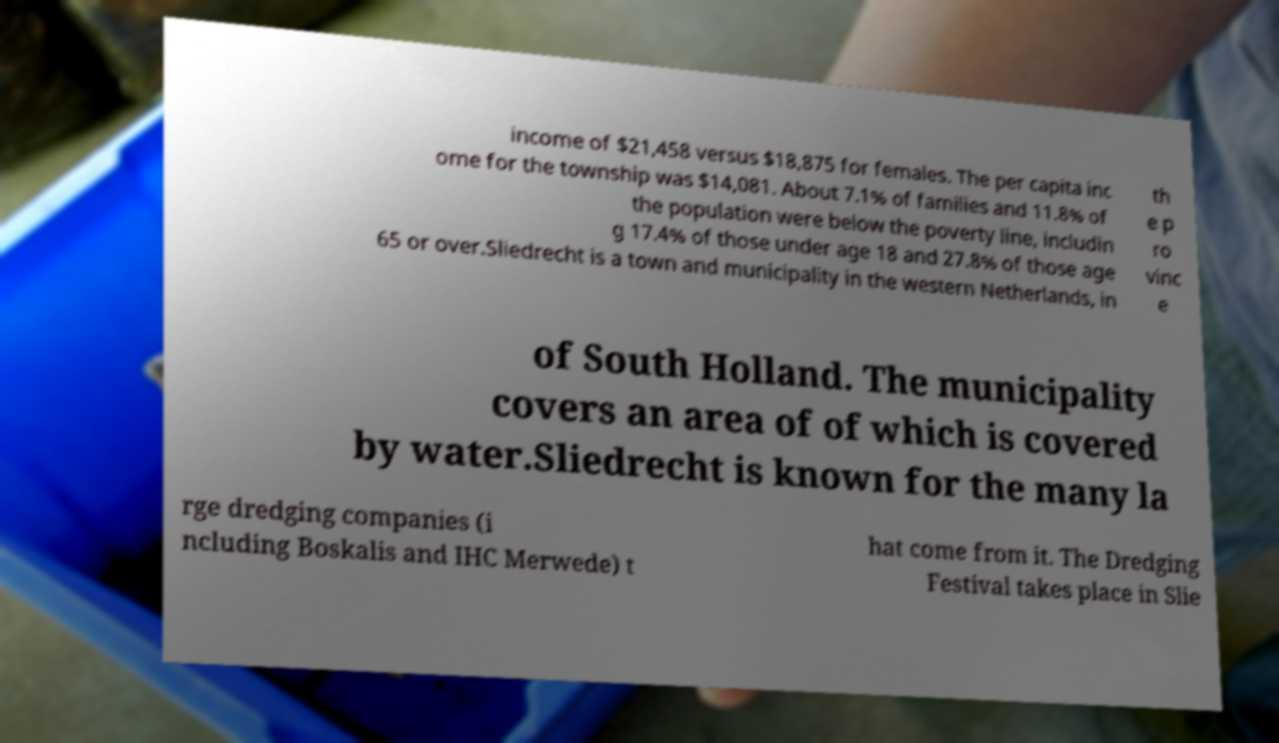Can you accurately transcribe the text from the provided image for me? income of $21,458 versus $18,875 for females. The per capita inc ome for the township was $14,081. About 7.1% of families and 11.8% of the population were below the poverty line, includin g 17.4% of those under age 18 and 27.8% of those age 65 or over.Sliedrecht is a town and municipality in the western Netherlands, in th e p ro vinc e of South Holland. The municipality covers an area of of which is covered by water.Sliedrecht is known for the many la rge dredging companies (i ncluding Boskalis and IHC Merwede) t hat come from it. The Dredging Festival takes place in Slie 